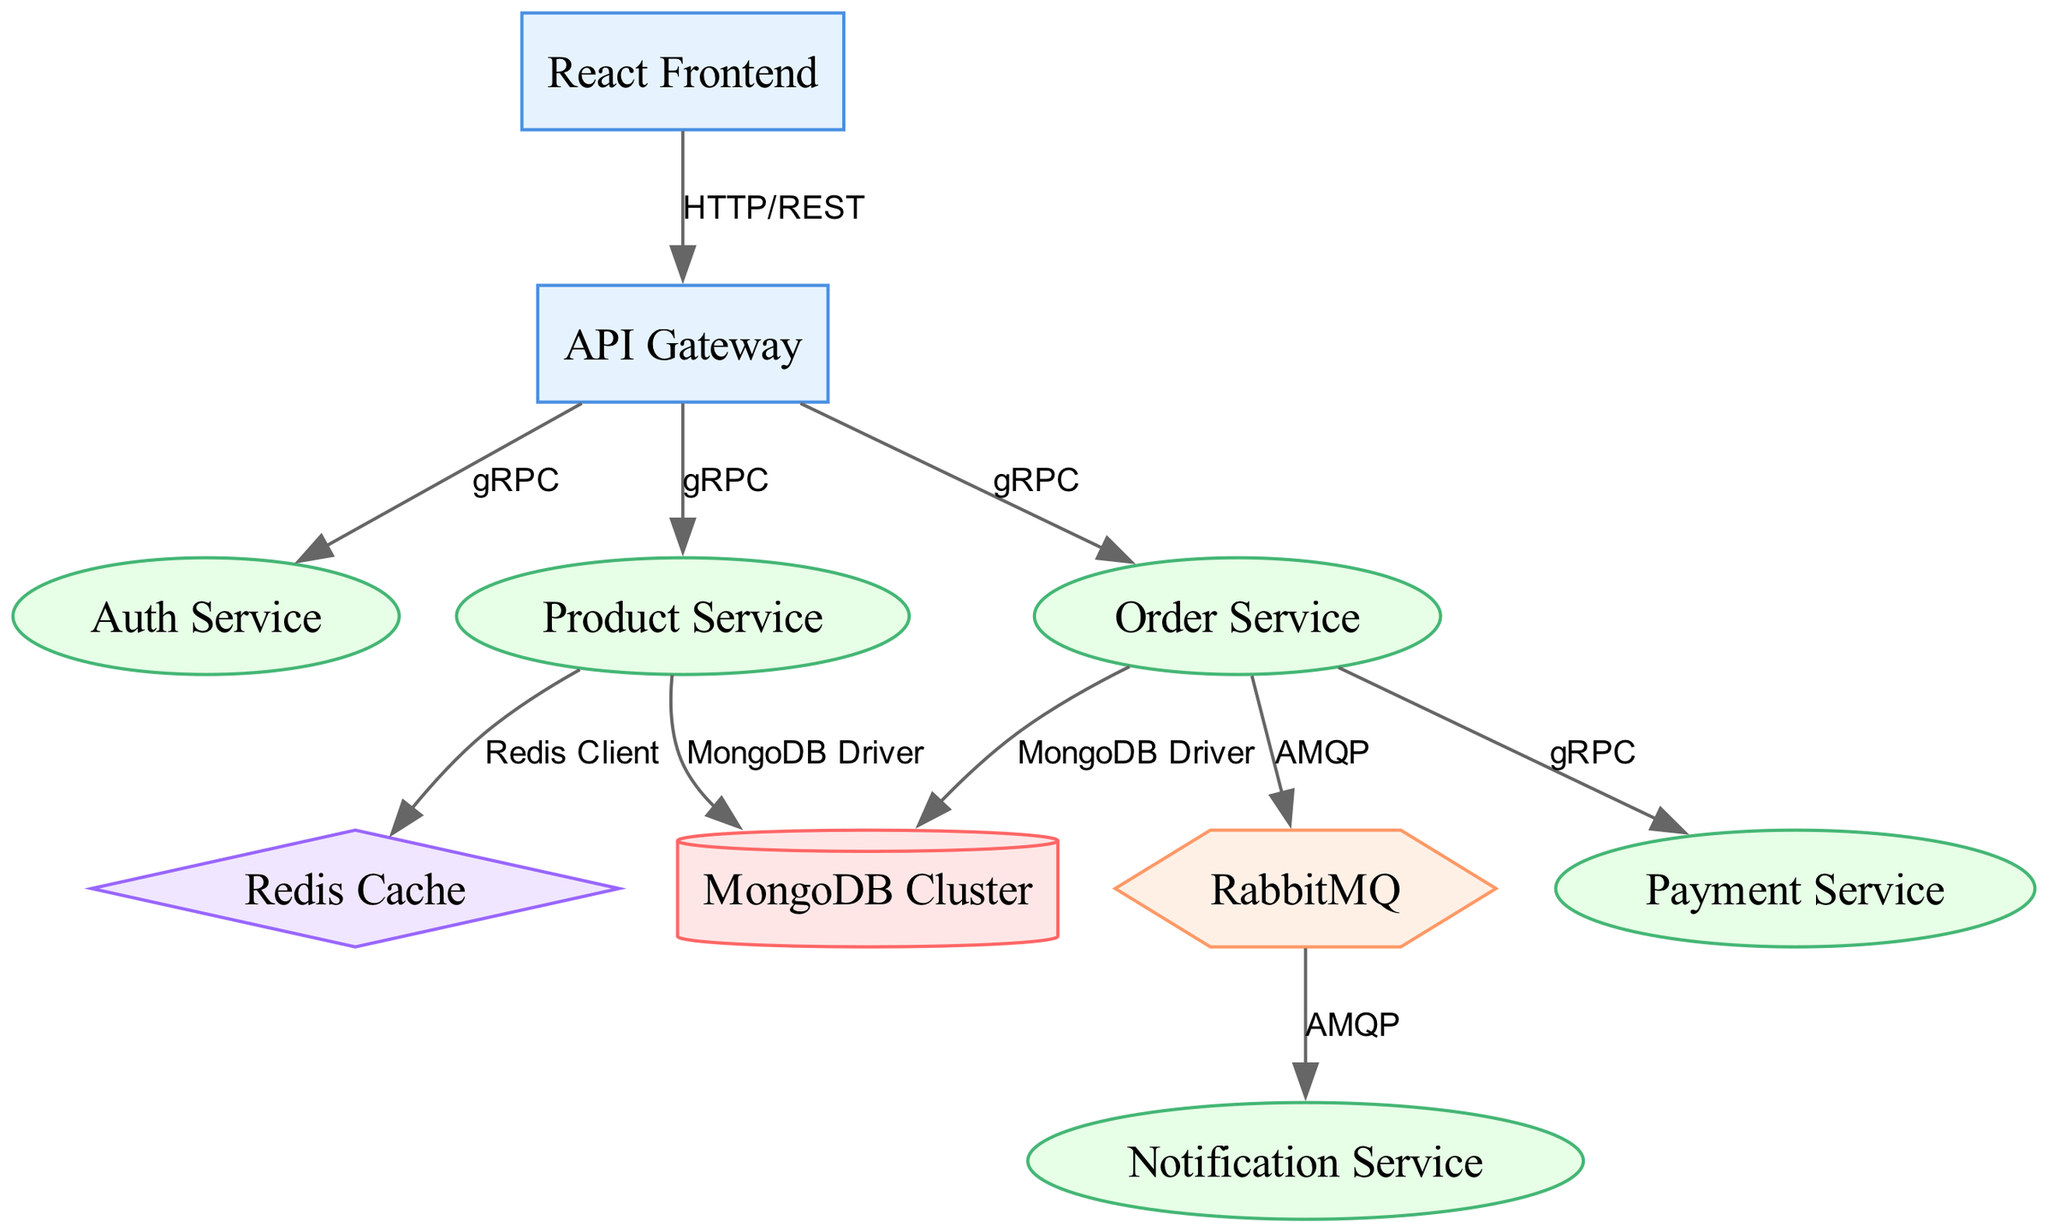What is the total number of nodes in the diagram? Counting the nodes listed in the 'nodes' section of the data, we find that there are 10 distinct nodes representing various components and services.
Answer: 10 What type of service is the 'Order Service'? Referring to the node labeled 'Order Service', it is categorized as a microservice, as indicated by its node type in the diagram.
Answer: microservice Which node connects to the 'Payment Service' and through what protocol? The 'Order Service' connects to the 'Payment Service' using the gRPC protocol, as shown by the edge labeled between these two nodes in the diagram.
Answer: gRPC How many edges are present in the diagram? By reviewing the 'edges' section of the data, we count a total of 9 edges representing connections between different nodes in the architecture.
Answer: 9 What type of database is associated with the 'Product Service'? The 'Product Service' connects to the 'MongoDB Cluster', which is indicated by the edge that states 'MongoDB Driver', showing the type of database used for this service.
Answer: MongoDB Cluster What is the main communication method between the 'Frontend' and the 'API Gateway'? The communication from 'Frontend' to 'API Gateway' is established through HTTP/REST, as specified in the edge connecting these two nodes.
Answer: HTTP/REST Which service is responsible for handling notifications in this architecture? The 'Notification Service' is indicated as the service responsible for handling notifications, and it is represented in the diagram as a distinct microservice.
Answer: Notification Service Can 'Product Service' access the cache, and if so, what technology does it use? Yes, the 'Product Service' can access the 'Redis Cache' using the Redis Client, as indicated by the edge connecting these two elements in the diagram.
Answer: Redis Client Which microservice directly interacts with the 'Message Queue'? The 'Order Service' directly interacts with the 'RabbitMQ' (Message Queue) through an AMQP connection, as shown in the edge that links these two components.
Answer: Order Service 